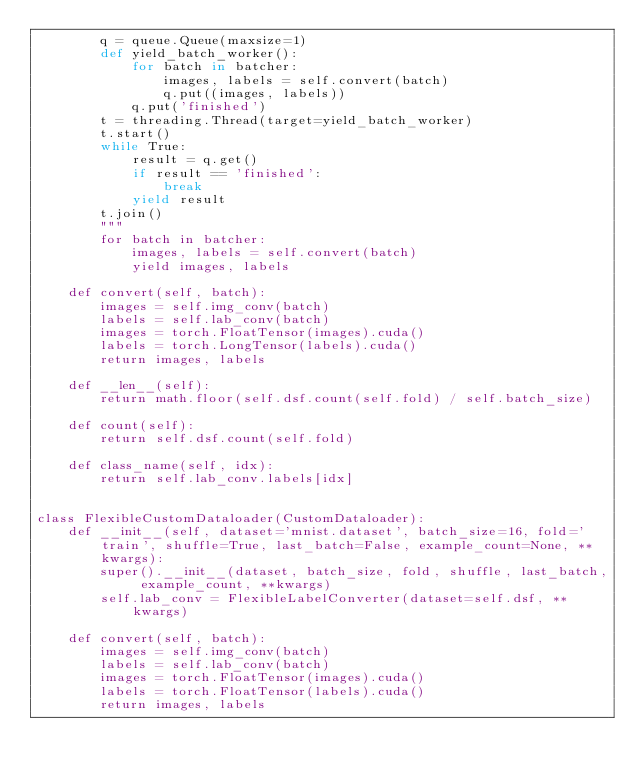Convert code to text. <code><loc_0><loc_0><loc_500><loc_500><_Python_>        q = queue.Queue(maxsize=1)
        def yield_batch_worker():
            for batch in batcher:
                images, labels = self.convert(batch)
                q.put((images, labels))
            q.put('finished')
        t = threading.Thread(target=yield_batch_worker)
        t.start()
        while True:
            result = q.get()
            if result == 'finished':
                break
            yield result
        t.join()
        """
        for batch in batcher:
            images, labels = self.convert(batch)
            yield images, labels

    def convert(self, batch):
        images = self.img_conv(batch)
        labels = self.lab_conv(batch)
        images = torch.FloatTensor(images).cuda()
        labels = torch.LongTensor(labels).cuda()
        return images, labels

    def __len__(self):
        return math.floor(self.dsf.count(self.fold) / self.batch_size)

    def count(self):
        return self.dsf.count(self.fold)

    def class_name(self, idx):
        return self.lab_conv.labels[idx]


class FlexibleCustomDataloader(CustomDataloader):
    def __init__(self, dataset='mnist.dataset', batch_size=16, fold='train', shuffle=True, last_batch=False, example_count=None, **kwargs):
        super().__init__(dataset, batch_size, fold, shuffle, last_batch, example_count, **kwargs)
        self.lab_conv = FlexibleLabelConverter(dataset=self.dsf, **kwargs)

    def convert(self, batch):
        images = self.img_conv(batch)
        labels = self.lab_conv(batch)
        images = torch.FloatTensor(images).cuda()
        labels = torch.FloatTensor(labels).cuda()
        return images, labels</code> 